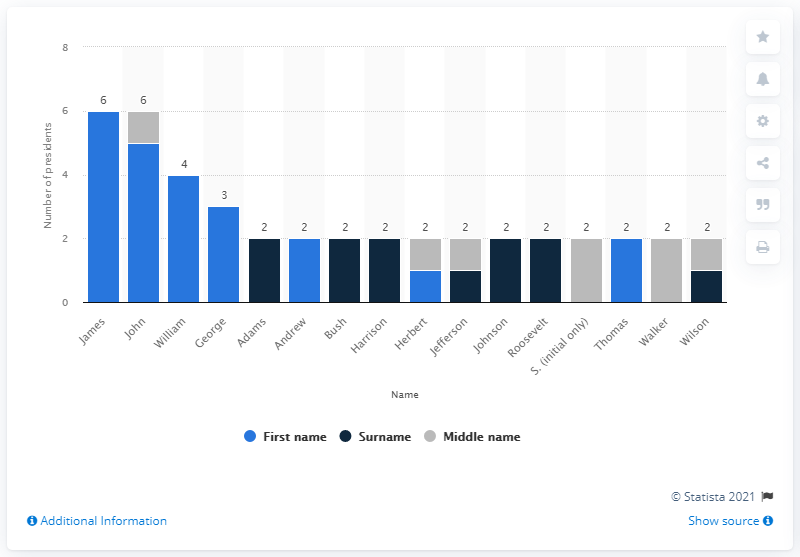Mention a couple of crucial points in this snapshot. James is the most common first name among U.S. presidents. The second most common first name for a U.S. president is John. 